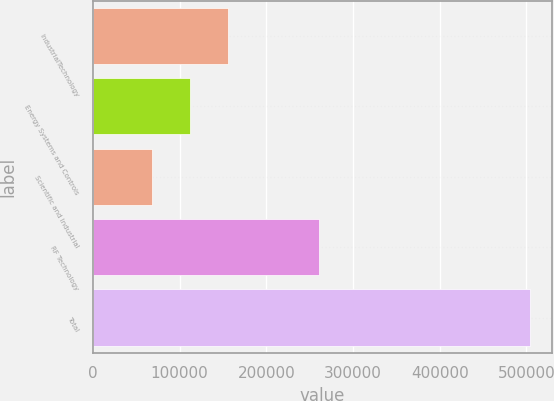Convert chart. <chart><loc_0><loc_0><loc_500><loc_500><bar_chart><fcel>IndustrialTechnology<fcel>Energy Systems and Controls<fcel>Scientific and Industrial<fcel>RF Technology<fcel>Total<nl><fcel>155800<fcel>112200<fcel>68600<fcel>261243<fcel>504599<nl></chart> 